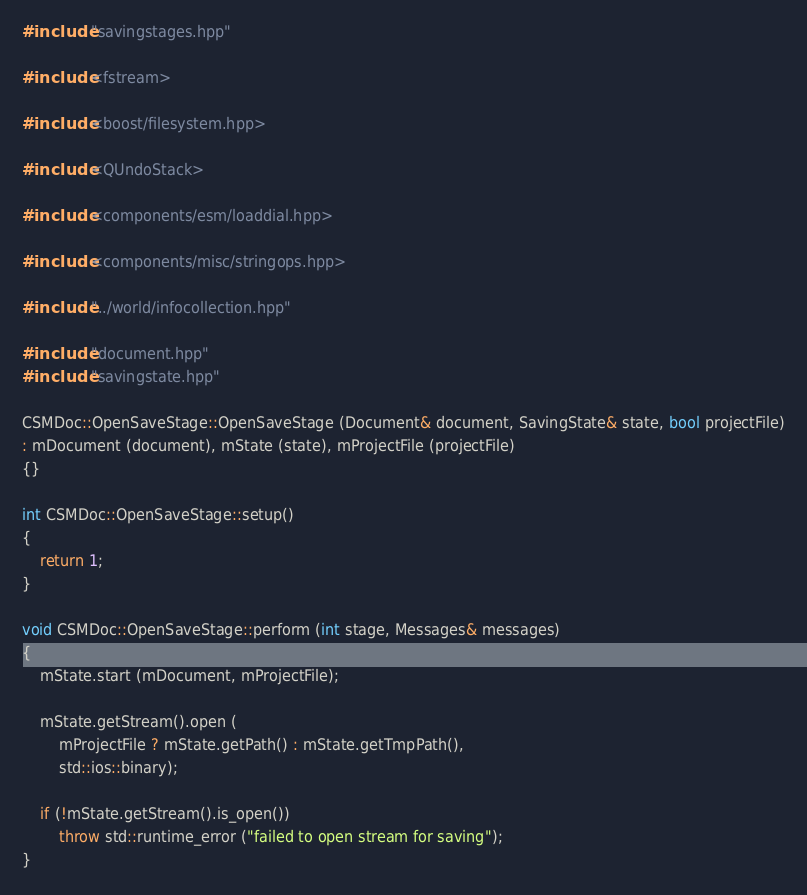Convert code to text. <code><loc_0><loc_0><loc_500><loc_500><_C++_>
#include "savingstages.hpp"

#include <fstream>

#include <boost/filesystem.hpp>

#include <QUndoStack>

#include <components/esm/loaddial.hpp>

#include <components/misc/stringops.hpp>

#include "../world/infocollection.hpp"

#include "document.hpp"
#include "savingstate.hpp"

CSMDoc::OpenSaveStage::OpenSaveStage (Document& document, SavingState& state, bool projectFile)
: mDocument (document), mState (state), mProjectFile (projectFile)
{}

int CSMDoc::OpenSaveStage::setup()
{
    return 1;
}

void CSMDoc::OpenSaveStage::perform (int stage, Messages& messages)
{
    mState.start (mDocument, mProjectFile);

    mState.getStream().open (
        mProjectFile ? mState.getPath() : mState.getTmpPath(),
        std::ios::binary);

    if (!mState.getStream().is_open())
        throw std::runtime_error ("failed to open stream for saving");
}

</code> 